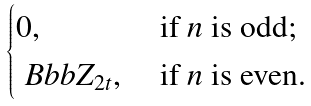Convert formula to latex. <formula><loc_0><loc_0><loc_500><loc_500>\begin{cases} 0 , & \text { if } n \text { is odd;} \\ { \ B b b Z } _ { 2 t } , & \text { if } n \text { is even.} \end{cases}</formula> 